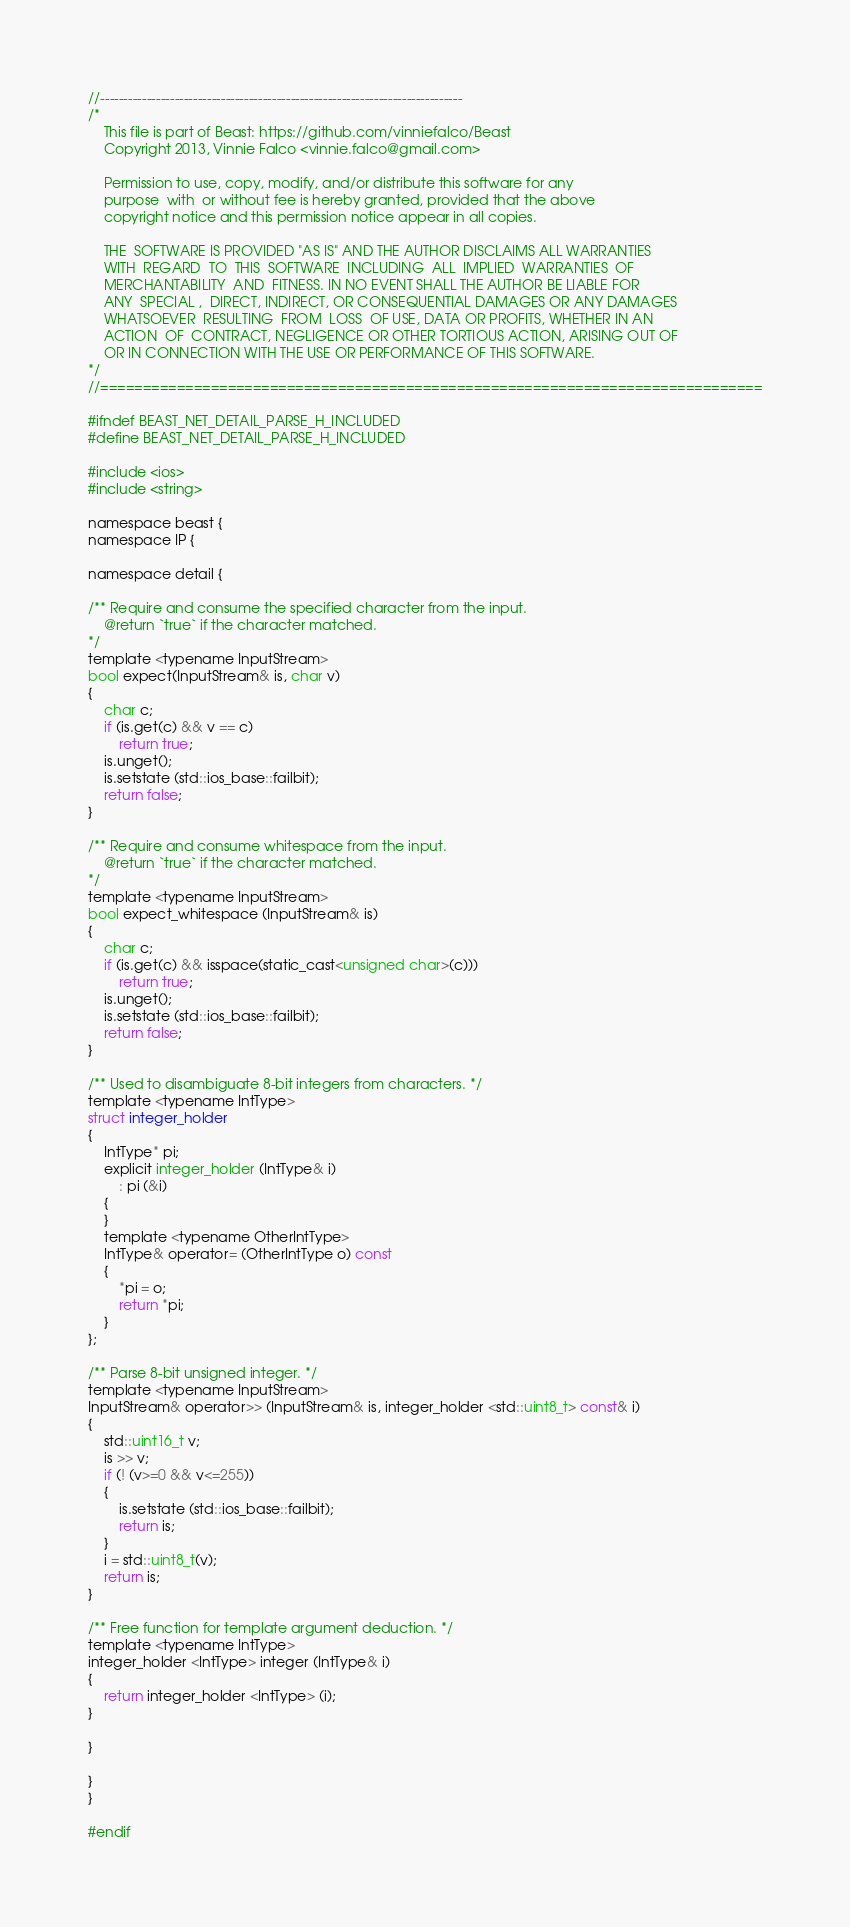<code> <loc_0><loc_0><loc_500><loc_500><_C_>//------------------------------------------------------------------------------
/*
    This file is part of Beast: https://github.com/vinniefalco/Beast
    Copyright 2013, Vinnie Falco <vinnie.falco@gmail.com>

    Permission to use, copy, modify, and/or distribute this software for any
    purpose  with  or without fee is hereby granted, provided that the above
    copyright notice and this permission notice appear in all copies.

    THE  SOFTWARE IS PROVIDED "AS IS" AND THE AUTHOR DISCLAIMS ALL WARRANTIES
    WITH  REGARD  TO  THIS  SOFTWARE  INCLUDING  ALL  IMPLIED  WARRANTIES  OF
    MERCHANTABILITY  AND  FITNESS. IN NO EVENT SHALL THE AUTHOR BE LIABLE FOR
    ANY  SPECIAL ,  DIRECT, INDIRECT, OR CONSEQUENTIAL DAMAGES OR ANY DAMAGES
    WHATSOEVER  RESULTING  FROM  LOSS  OF USE, DATA OR PROFITS, WHETHER IN AN
    ACTION  OF  CONTRACT, NEGLIGENCE OR OTHER TORTIOUS ACTION, ARISING OUT OF
    OR IN CONNECTION WITH THE USE OR PERFORMANCE OF THIS SOFTWARE.
*/
//==============================================================================

#ifndef BEAST_NET_DETAIL_PARSE_H_INCLUDED
#define BEAST_NET_DETAIL_PARSE_H_INCLUDED

#include <ios>
#include <string>

namespace beast {
namespace IP {

namespace detail {

/** Require and consume the specified character from the input.
    @return `true` if the character matched.
*/
template <typename InputStream>
bool expect(InputStream& is, char v)
{
    char c;
    if (is.get(c) && v == c)
        return true;
    is.unget();
    is.setstate (std::ios_base::failbit);
    return false;
}

/** Require and consume whitespace from the input.
    @return `true` if the character matched.
*/
template <typename InputStream>
bool expect_whitespace (InputStream& is)
{
    char c;
    if (is.get(c) && isspace(static_cast<unsigned char>(c)))
        return true;
    is.unget();
    is.setstate (std::ios_base::failbit);
    return false;
}

/** Used to disambiguate 8-bit integers from characters. */
template <typename IntType>
struct integer_holder
{
    IntType* pi;
    explicit integer_holder (IntType& i)
        : pi (&i)
    {
    }
    template <typename OtherIntType>
    IntType& operator= (OtherIntType o) const
    {
        *pi = o;
        return *pi;
    }
};

/** Parse 8-bit unsigned integer. */
template <typename InputStream>
InputStream& operator>> (InputStream& is, integer_holder <std::uint8_t> const& i)
{
    std::uint16_t v;
    is >> v;
    if (! (v>=0 && v<=255))
    {
        is.setstate (std::ios_base::failbit);
        return is;
    }
    i = std::uint8_t(v);
    return is;
}

/** Free function for template argument deduction. */
template <typename IntType>
integer_holder <IntType> integer (IntType& i)
{
    return integer_holder <IntType> (i);
}

}

}
}

#endif
</code> 